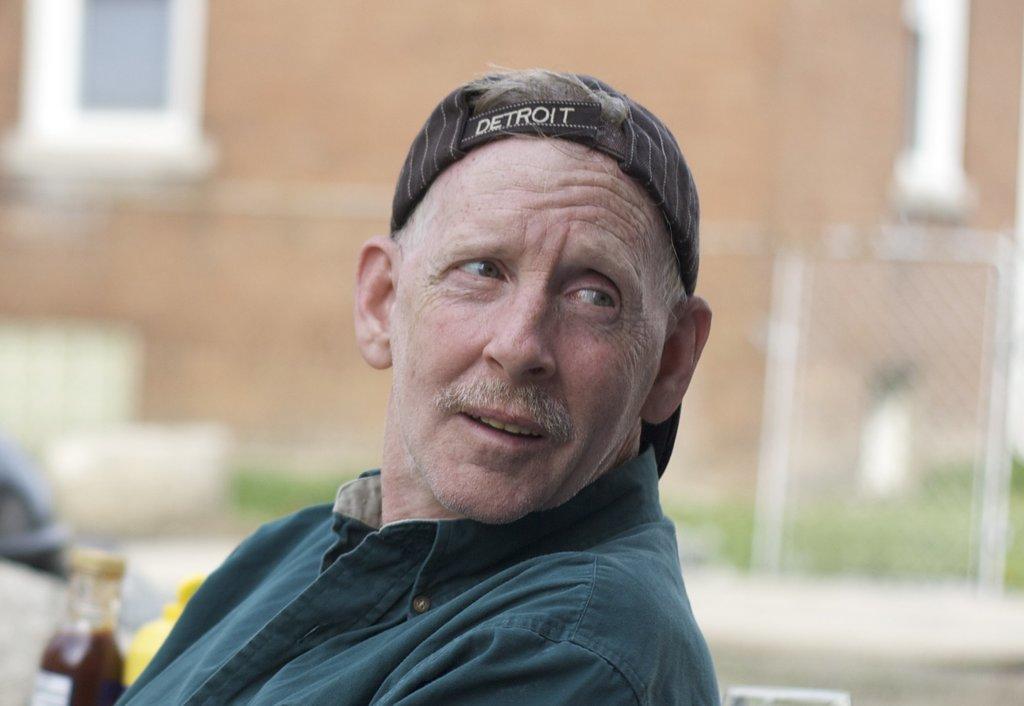Please provide a concise description of this image. In the center of the image there is a man. He is wearing a cap. In the background there is a building and a mesh. 